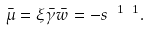Convert formula to latex. <formula><loc_0><loc_0><loc_500><loc_500>\bar { \mu } = \xi \bar { \gamma } \bar { w } = - s ^ { \ 1 \ 1 } .</formula> 